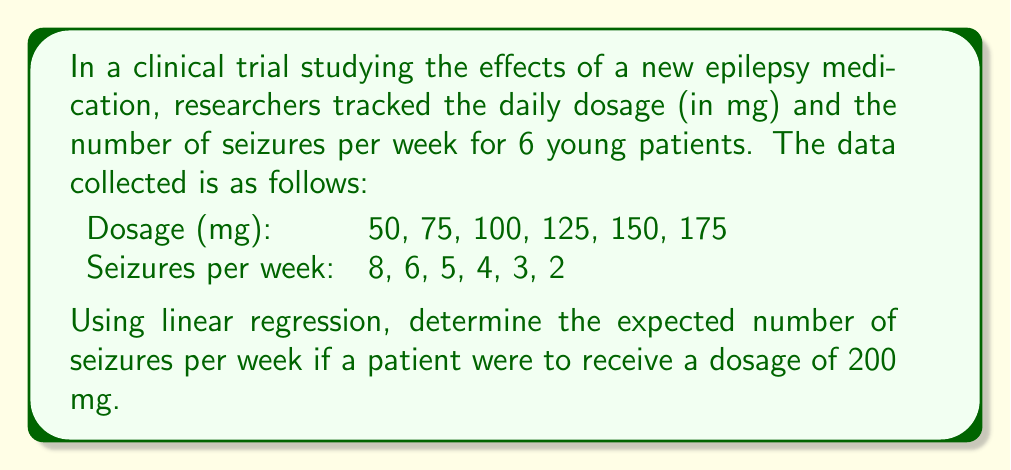Teach me how to tackle this problem. To solve this problem, we'll use linear regression to find the line of best fit and then use it to predict the number of seizures for a 200 mg dosage.

Step 1: Calculate the means of x (dosage) and y (seizures)
$\bar{x} = \frac{50 + 75 + 100 + 125 + 150 + 175}{6} = 112.5$
$\bar{y} = \frac{8 + 6 + 5 + 4 + 3 + 2}{6} = 4.67$

Step 2: Calculate the slope (m) using the formula:
$m = \frac{\sum(x_i - \bar{x})(y_i - \bar{y})}{\sum(x_i - \bar{x})^2}$

$\sum(x_i - \bar{x})(y_i - \bar{y}) = -3937.5$
$\sum(x_i - \bar{x})^2 = 15,625$

$m = \frac{-3937.5}{15,625} = -0.252$

Step 3: Calculate the y-intercept (b) using the formula:
$b = \bar{y} - m\bar{x}$
$b = 4.67 - (-0.252 \times 112.5) = 33.02$

Step 4: Write the equation of the line of best fit:
$y = mx + b$
$y = -0.252x + 33.02$

Step 5: Use the equation to predict the number of seizures for a 200 mg dosage:
$y = -0.252(200) + 33.02 = 16.62$

Therefore, the expected number of seizures per week for a 200 mg dosage is approximately 0.62.
Answer: 0.62 seizures per week 